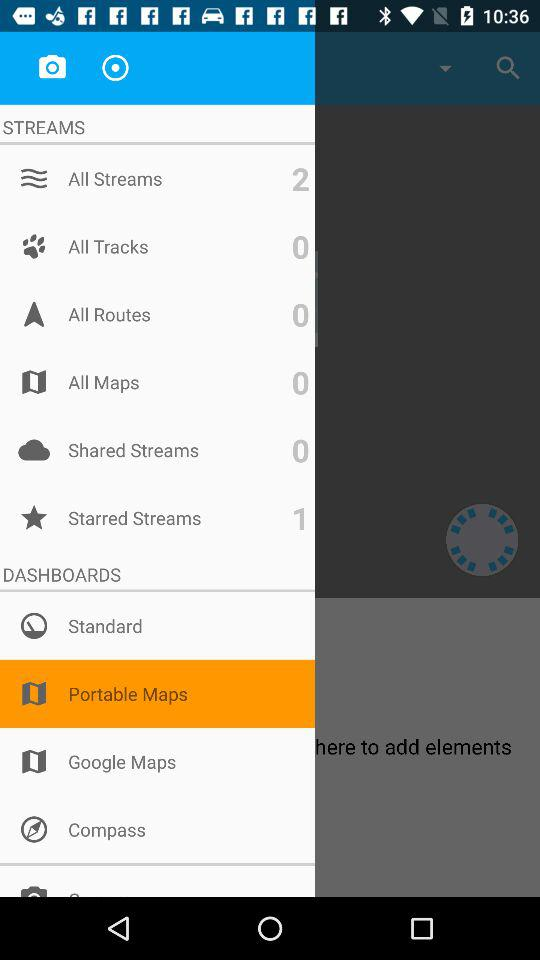How many streams in total are there? There are 2 streams. 